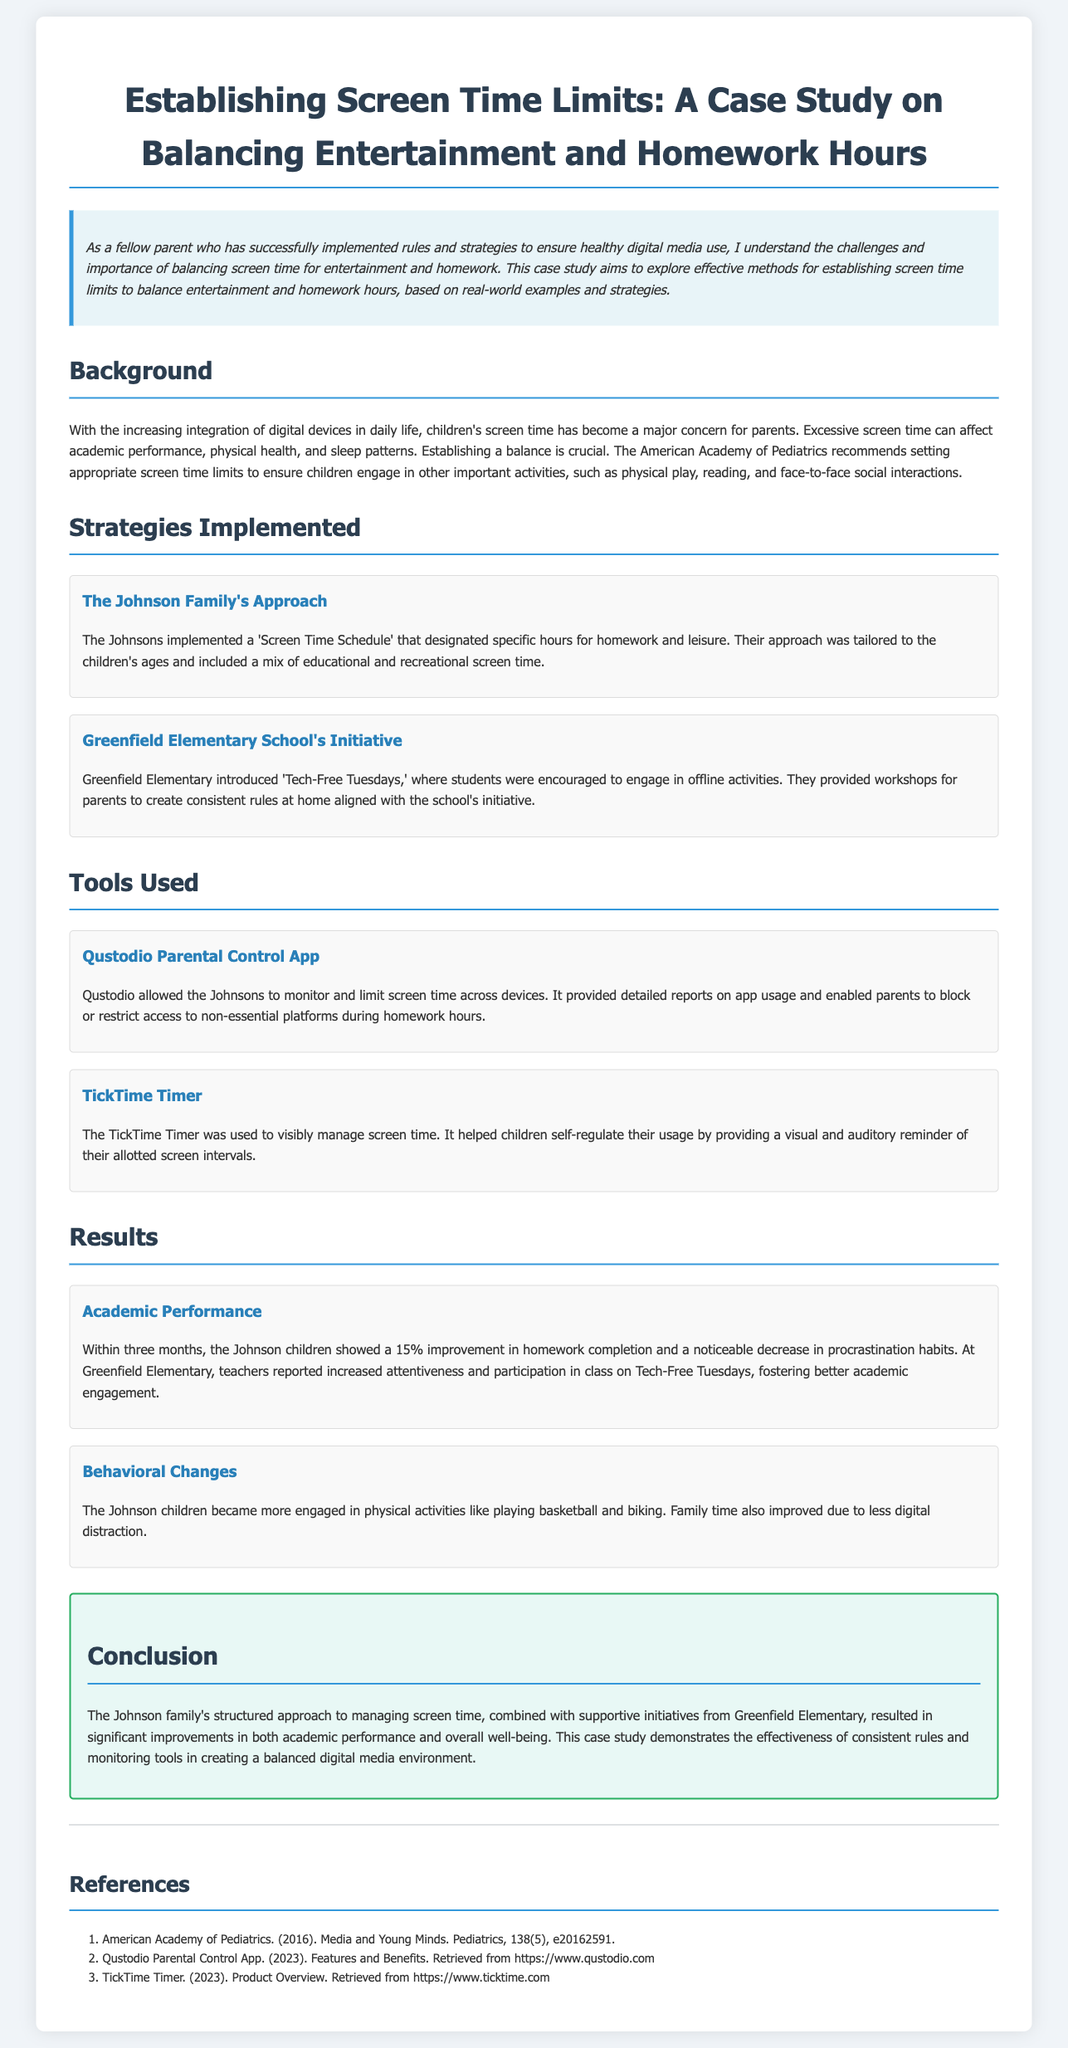what is the main focus of the case study? The main focus of the case study is on establishing screen time limits to balance entertainment and homework hours.
Answer: balancing entertainment and homework hours who is the family mentioned in the case study? The family mentioned in the case study is the Johnson family.
Answer: Johnson family what tool did the Johnsons use to monitor screen time? The Johnsons used the Qustodio Parental Control App to monitor screen time.
Answer: Qustodio Parental Control App which day was designated as 'Tech-Free' at Greenfield Elementary? 'Tech-Free Tuesdays' was designated at Greenfield Elementary.
Answer: Tech-Free Tuesdays what percentage improvement did the Johnson children show in homework completion? The Johnson children showed a 15% improvement in homework completion.
Answer: 15% what behavioral change was noted in the Johnson children? The Johnson children became more engaged in physical activities.
Answer: engaged in physical activities what did the TickTime Timer help children to do? The TickTime Timer helped children self-regulate their usage of screen time.
Answer: self-regulate their usage who provided workshops for parents parallel to the school's initiative? Greenfield Elementary provided workshops for parents.
Answer: Greenfield Elementary which organization recommends setting appropriate screen time limits? The American Academy of Pediatrics recommends setting appropriate screen time limits.
Answer: American Academy of Pediatrics 